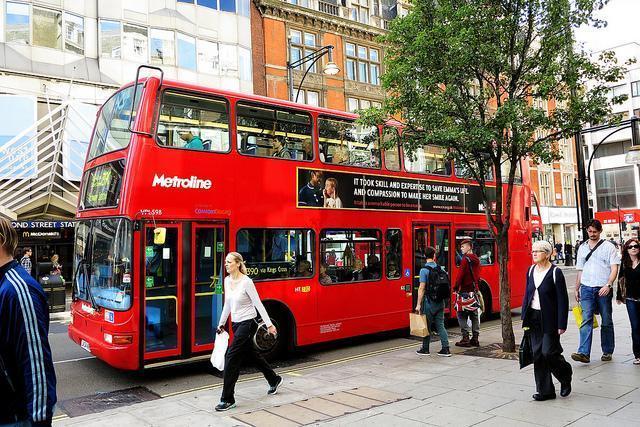How many buses are there?
Give a very brief answer. 1. How many people are in the photo?
Give a very brief answer. 6. How many keyboards are in the picture?
Give a very brief answer. 0. 